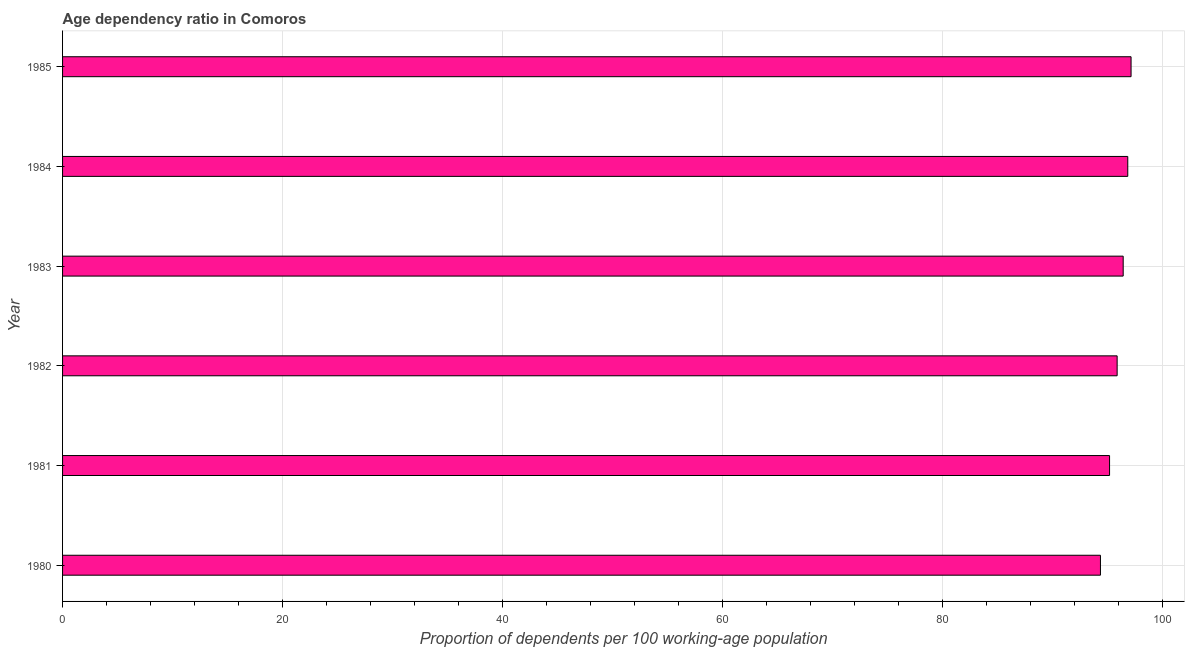Does the graph contain grids?
Offer a very short reply. Yes. What is the title of the graph?
Your response must be concise. Age dependency ratio in Comoros. What is the label or title of the X-axis?
Offer a very short reply. Proportion of dependents per 100 working-age population. What is the label or title of the Y-axis?
Your answer should be very brief. Year. What is the age dependency ratio in 1982?
Offer a terse response. 95.87. Across all years, what is the maximum age dependency ratio?
Give a very brief answer. 97.14. Across all years, what is the minimum age dependency ratio?
Make the answer very short. 94.36. In which year was the age dependency ratio minimum?
Make the answer very short. 1980. What is the sum of the age dependency ratio?
Give a very brief answer. 575.82. What is the difference between the age dependency ratio in 1980 and 1985?
Give a very brief answer. -2.78. What is the average age dependency ratio per year?
Your answer should be compact. 95.97. What is the median age dependency ratio?
Keep it short and to the point. 96.15. What is the difference between the highest and the second highest age dependency ratio?
Make the answer very short. 0.3. Is the sum of the age dependency ratio in 1984 and 1985 greater than the maximum age dependency ratio across all years?
Make the answer very short. Yes. What is the difference between the highest and the lowest age dependency ratio?
Make the answer very short. 2.78. In how many years, is the age dependency ratio greater than the average age dependency ratio taken over all years?
Offer a very short reply. 3. How many bars are there?
Provide a succinct answer. 6. How many years are there in the graph?
Your answer should be very brief. 6. What is the difference between two consecutive major ticks on the X-axis?
Offer a terse response. 20. What is the Proportion of dependents per 100 working-age population in 1980?
Ensure brevity in your answer.  94.36. What is the Proportion of dependents per 100 working-age population of 1981?
Provide a succinct answer. 95.18. What is the Proportion of dependents per 100 working-age population of 1982?
Your response must be concise. 95.87. What is the Proportion of dependents per 100 working-age population of 1983?
Offer a very short reply. 96.42. What is the Proportion of dependents per 100 working-age population in 1984?
Give a very brief answer. 96.84. What is the Proportion of dependents per 100 working-age population in 1985?
Ensure brevity in your answer.  97.14. What is the difference between the Proportion of dependents per 100 working-age population in 1980 and 1981?
Your answer should be very brief. -0.83. What is the difference between the Proportion of dependents per 100 working-age population in 1980 and 1982?
Keep it short and to the point. -1.52. What is the difference between the Proportion of dependents per 100 working-age population in 1980 and 1983?
Your answer should be very brief. -2.07. What is the difference between the Proportion of dependents per 100 working-age population in 1980 and 1984?
Give a very brief answer. -2.48. What is the difference between the Proportion of dependents per 100 working-age population in 1980 and 1985?
Your response must be concise. -2.78. What is the difference between the Proportion of dependents per 100 working-age population in 1981 and 1982?
Offer a terse response. -0.69. What is the difference between the Proportion of dependents per 100 working-age population in 1981 and 1983?
Offer a very short reply. -1.24. What is the difference between the Proportion of dependents per 100 working-age population in 1981 and 1984?
Your answer should be very brief. -1.65. What is the difference between the Proportion of dependents per 100 working-age population in 1981 and 1985?
Your answer should be very brief. -1.95. What is the difference between the Proportion of dependents per 100 working-age population in 1982 and 1983?
Give a very brief answer. -0.55. What is the difference between the Proportion of dependents per 100 working-age population in 1982 and 1984?
Your answer should be compact. -0.97. What is the difference between the Proportion of dependents per 100 working-age population in 1982 and 1985?
Offer a terse response. -1.27. What is the difference between the Proportion of dependents per 100 working-age population in 1983 and 1984?
Keep it short and to the point. -0.42. What is the difference between the Proportion of dependents per 100 working-age population in 1983 and 1985?
Keep it short and to the point. -0.72. What is the difference between the Proportion of dependents per 100 working-age population in 1984 and 1985?
Your response must be concise. -0.3. What is the ratio of the Proportion of dependents per 100 working-age population in 1981 to that in 1982?
Ensure brevity in your answer.  0.99. What is the ratio of the Proportion of dependents per 100 working-age population in 1981 to that in 1984?
Give a very brief answer. 0.98. What is the ratio of the Proportion of dependents per 100 working-age population in 1982 to that in 1985?
Offer a very short reply. 0.99. What is the ratio of the Proportion of dependents per 100 working-age population in 1983 to that in 1985?
Make the answer very short. 0.99. 